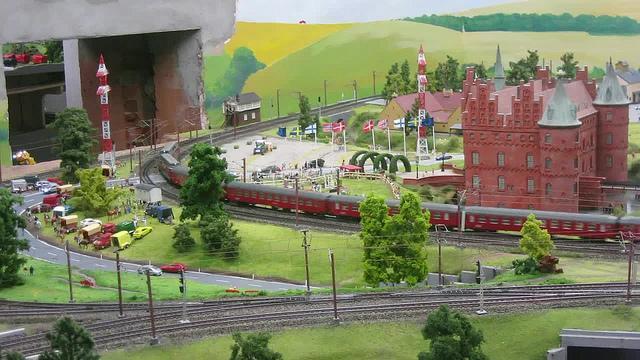How many trains are there?
Give a very brief answer. 1. How many people are playing tennis?
Give a very brief answer. 0. 